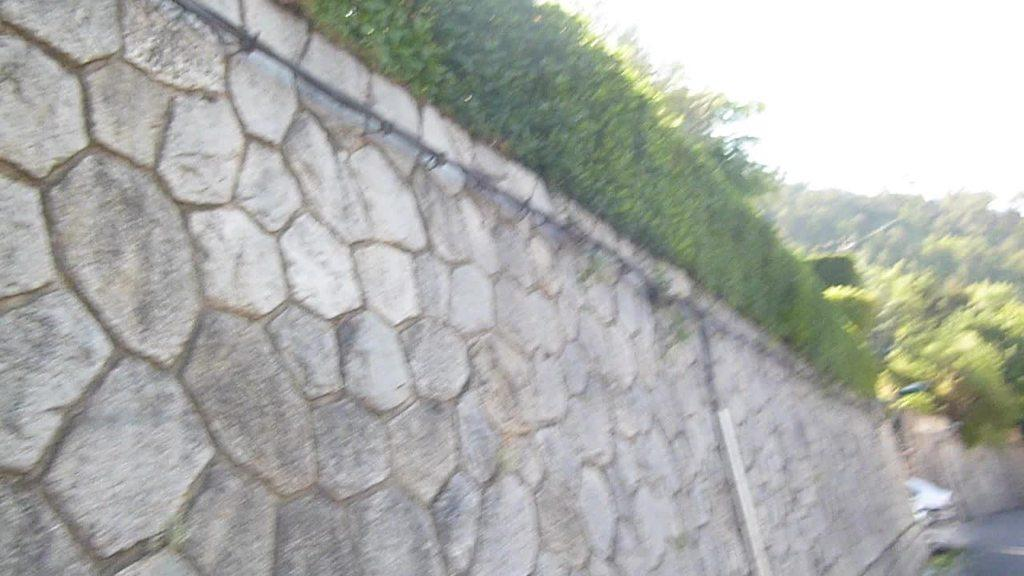What type of structure is visible in the image? There is a wall in the image. What type of vegetation can be seen in the image? There are plants and trees in the image. How many horses are present in the image? There are no horses present in the image. What type of feast is being prepared in the image? There is no feast or preparation for a feast visible in the image. 